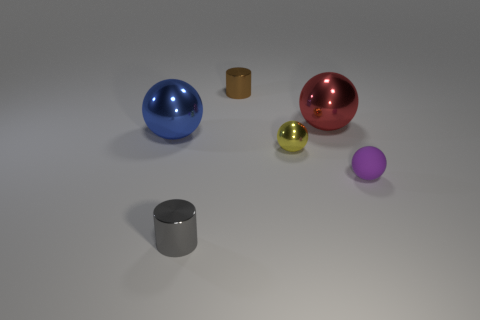Subtract all brown balls. Subtract all red cubes. How many balls are left? 4 Add 3 tiny yellow balls. How many objects exist? 9 Subtract all balls. How many objects are left? 2 Subtract 1 gray cylinders. How many objects are left? 5 Subtract all tiny yellow objects. Subtract all blue balls. How many objects are left? 4 Add 2 metal balls. How many metal balls are left? 5 Add 6 red metal balls. How many red metal balls exist? 7 